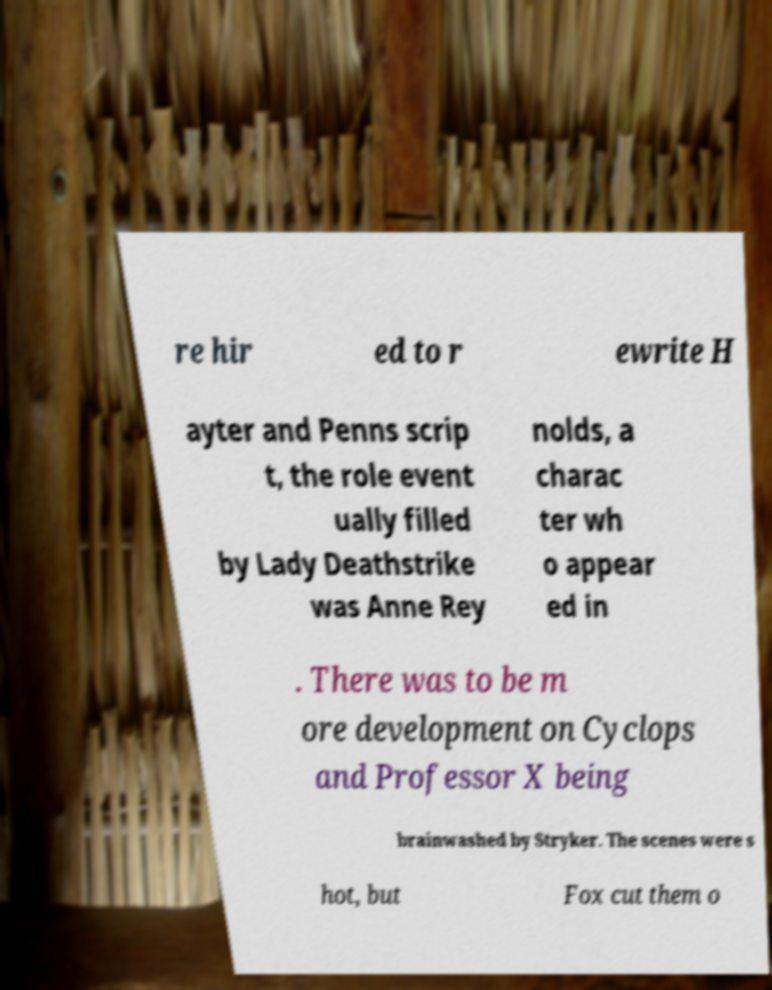Could you assist in decoding the text presented in this image and type it out clearly? re hir ed to r ewrite H ayter and Penns scrip t, the role event ually filled by Lady Deathstrike was Anne Rey nolds, a charac ter wh o appear ed in . There was to be m ore development on Cyclops and Professor X being brainwashed by Stryker. The scenes were s hot, but Fox cut them o 